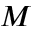<formula> <loc_0><loc_0><loc_500><loc_500>M</formula> 